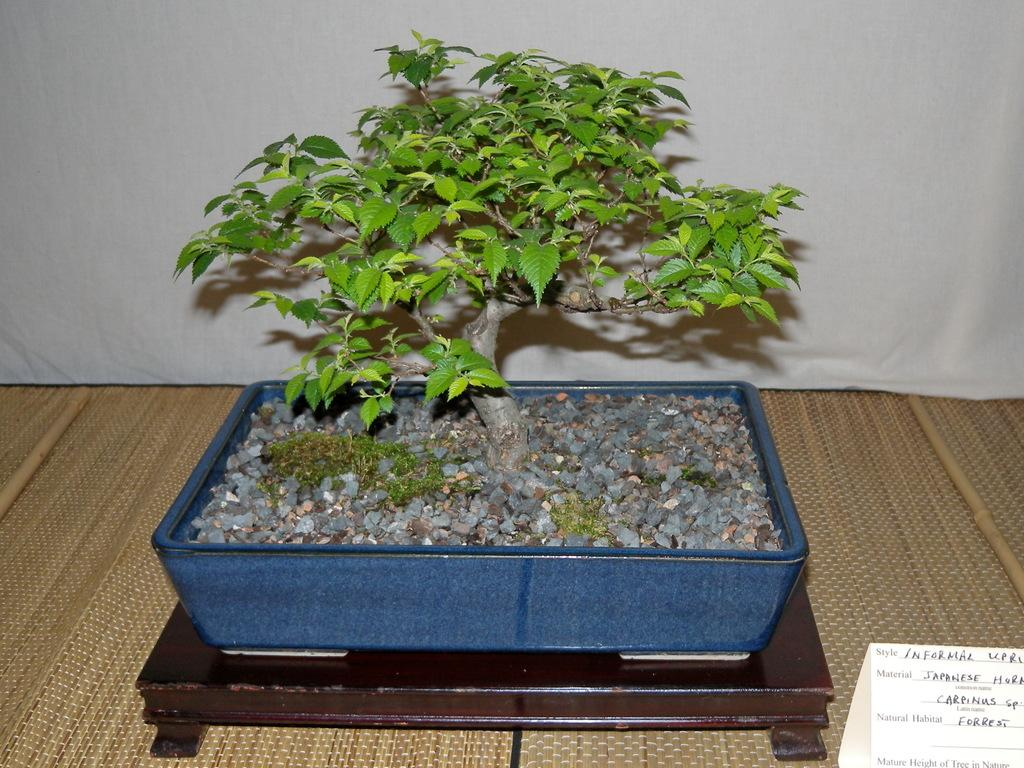What type of plant can be seen in the image? There is a house plant in the image. What other objects are present in the image besides the plant? There are crystal stones and a mat in the image. What type of material might the mat be made of? The mat could be made of various materials, but without more information, we cannot determine its specific composition. What is the paper used for in the image? The purpose of the paper in the image cannot be determined without more context. What type of coach is visible in the image? There is no coach present in the image. Can you tell me how many seeds are in the crystal stones? There are no seeds mentioned or visible in the image; it features a house plant, crystal stones, and a mat. 